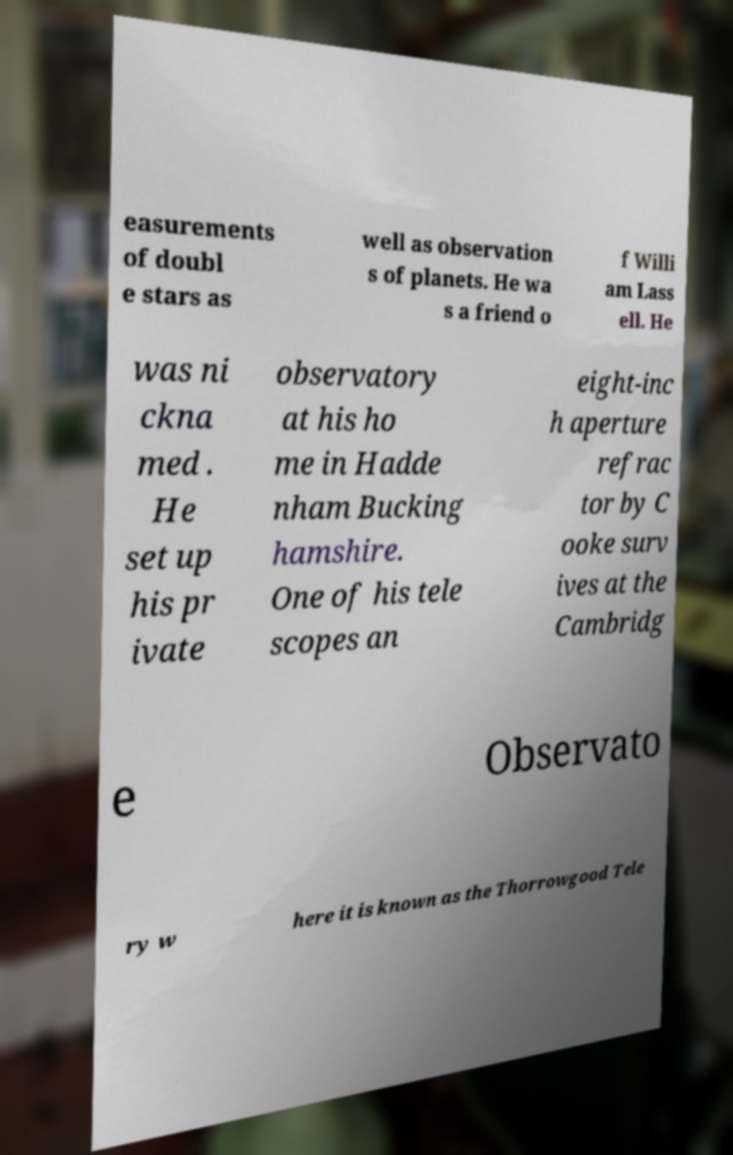Could you assist in decoding the text presented in this image and type it out clearly? easurements of doubl e stars as well as observation s of planets. He wa s a friend o f Willi am Lass ell. He was ni ckna med . He set up his pr ivate observatory at his ho me in Hadde nham Bucking hamshire. One of his tele scopes an eight-inc h aperture refrac tor by C ooke surv ives at the Cambridg e Observato ry w here it is known as the Thorrowgood Tele 